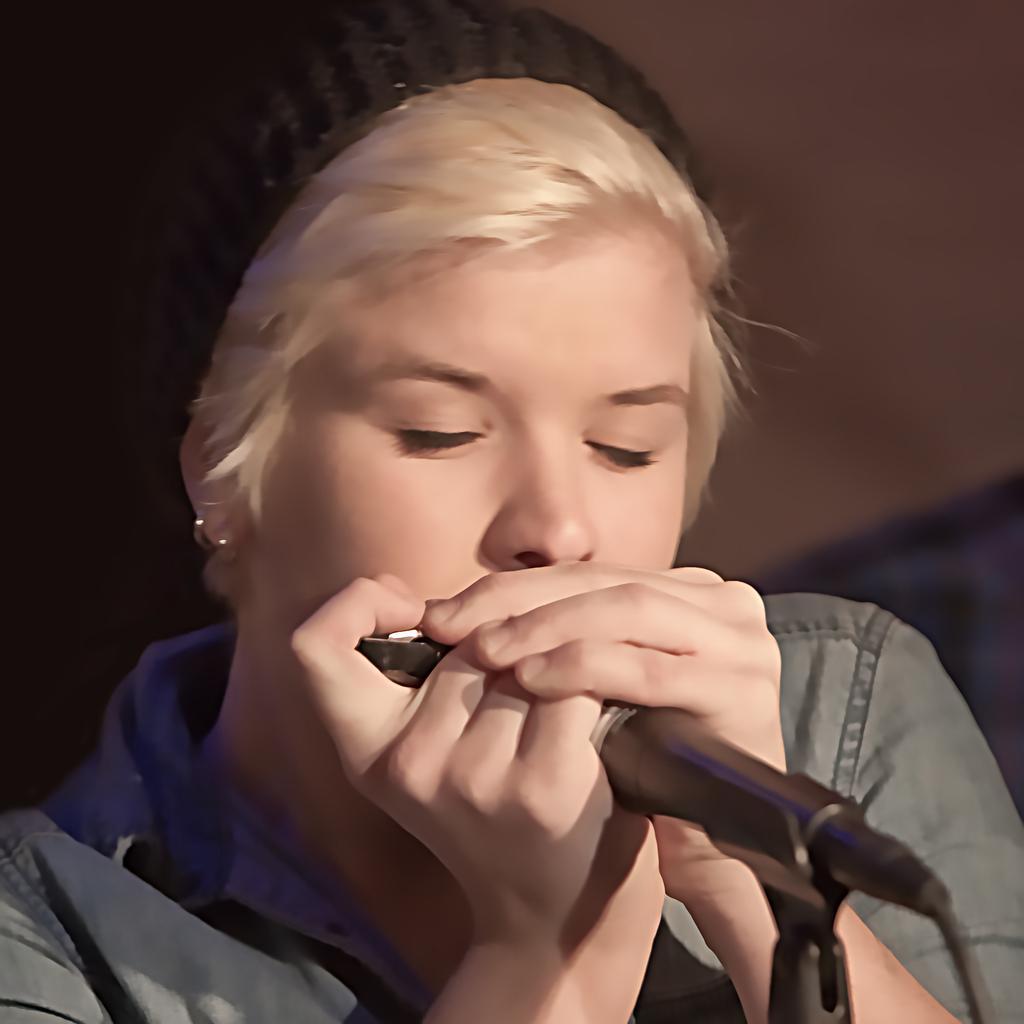Please provide a concise description of this image. In this picture we can observe a woman wearing a black color cap on her head. She is holding a mic in her hand. She is wearing a grey color shirt. In the background it is completely blur. 